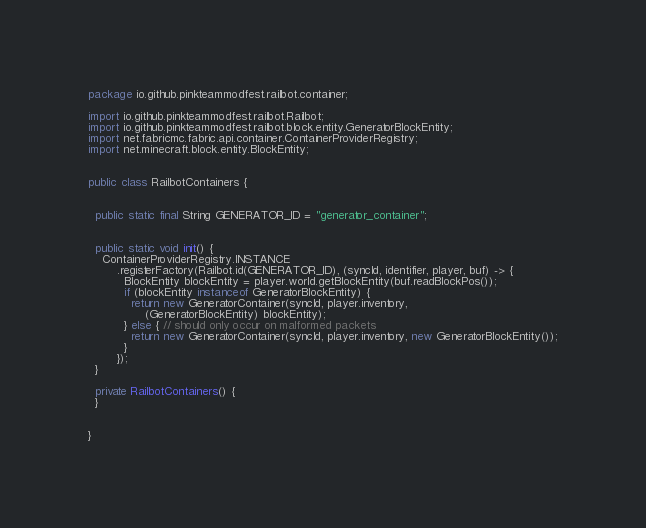Convert code to text. <code><loc_0><loc_0><loc_500><loc_500><_Java_>package io.github.pinkteammodfest.railbot.container;

import io.github.pinkteammodfest.railbot.Railbot;
import io.github.pinkteammodfest.railbot.block.entity.GeneratorBlockEntity;
import net.fabricmc.fabric.api.container.ContainerProviderRegistry;
import net.minecraft.block.entity.BlockEntity;


public class RailbotContainers {


  public static final String GENERATOR_ID = "generator_container";


  public static void init() {
    ContainerProviderRegistry.INSTANCE
        .registerFactory(Railbot.id(GENERATOR_ID), (syncId, identifier, player, buf) -> {
          BlockEntity blockEntity = player.world.getBlockEntity(buf.readBlockPos());
          if (blockEntity instanceof GeneratorBlockEntity) {
            return new GeneratorContainer(syncId, player.inventory,
                (GeneratorBlockEntity) blockEntity);
          } else { // should only occur on malformed packets
            return new GeneratorContainer(syncId, player.inventory, new GeneratorBlockEntity());
          }
        });
  }

  private RailbotContainers() {
  }


}
</code> 